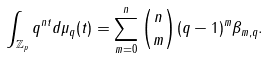Convert formula to latex. <formula><loc_0><loc_0><loc_500><loc_500>\int _ { \mathbb { Z } _ { p } } q ^ { n t } d \mu _ { q } ( t ) = \sum _ { m = 0 } ^ { n } \binom { n } { m } ( q - 1 ) ^ { m } \beta _ { m , q } .</formula> 